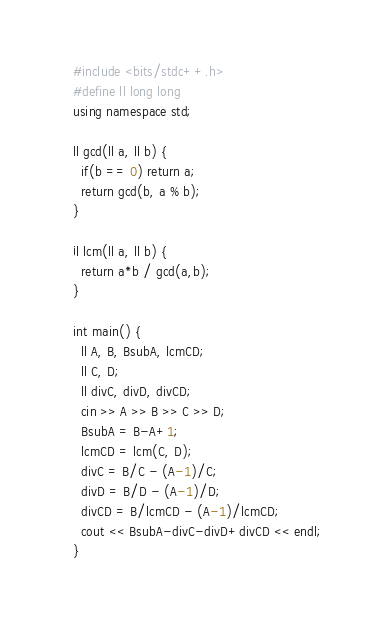<code> <loc_0><loc_0><loc_500><loc_500><_C++_>#include <bits/stdc++.h>
#define ll long long
using namespace std;

ll gcd(ll a, ll b) {
  if(b == 0) return a;
  return gcd(b, a % b);
}

ll lcm(ll a, ll b) {
  return a*b / gcd(a,b); 
}

int main() {
  ll A, B, BsubA, lcmCD;
  ll C, D;
  ll divC, divD, divCD;
  cin >> A >> B >> C >> D;
  BsubA = B-A+1;
  lcmCD = lcm(C, D);
  divC = B/C - (A-1)/C;
  divD = B/D - (A-1)/D;
  divCD = B/lcmCD - (A-1)/lcmCD;
  cout << BsubA-divC-divD+divCD << endl;
}</code> 